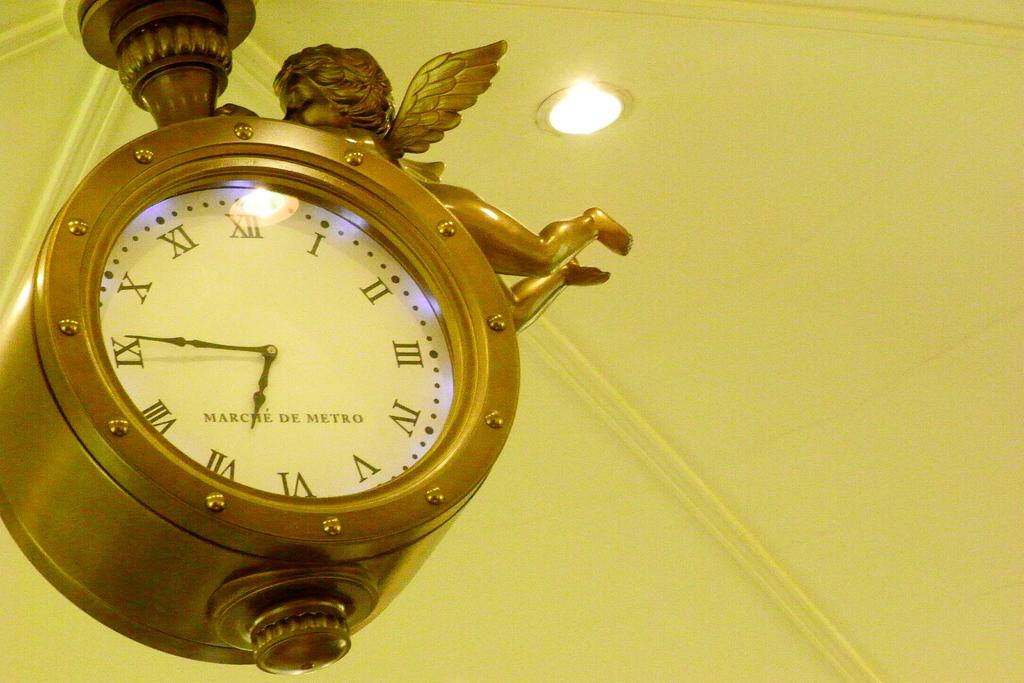What time is it??
Your answer should be compact. 6:46. What is the brand of this clock?
Keep it short and to the point. Marche de metro. 